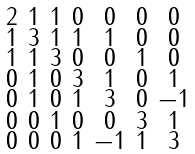Convert formula to latex. <formula><loc_0><loc_0><loc_500><loc_500>\begin{smallmatrix} 2 & 1 & 1 & 0 & 0 & 0 & 0 \\ 1 & 3 & 1 & 1 & 1 & 0 & 0 \\ 1 & 1 & 3 & 0 & 0 & 1 & 0 \\ 0 & 1 & 0 & 3 & 1 & 0 & 1 \\ 0 & 1 & 0 & 1 & 3 & 0 & - 1 \\ 0 & 0 & 1 & 0 & 0 & 3 & 1 \\ 0 & 0 & 0 & 1 & - 1 & 1 & 3 \end{smallmatrix}</formula> 